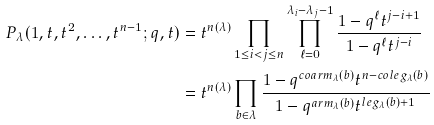<formula> <loc_0><loc_0><loc_500><loc_500>P _ { \lambda } ( 1 , t , t ^ { 2 } , \dots , t ^ { n - 1 } ; q , t ) & = t ^ { n ( \lambda ) } \prod _ { 1 \leq i < j \leq n } \prod _ { \ell = 0 } ^ { \lambda _ { i } - \lambda _ { j } - 1 } \frac { 1 - q ^ { \ell } t ^ { j - i + 1 } } { 1 - q ^ { \ell } t ^ { j - i } } \\ & = t ^ { n ( \lambda ) } \prod _ { b \in \lambda } \frac { 1 - q ^ { c o a r m _ { \lambda } ( b ) } t ^ { n - c o l e g _ { \lambda } ( b ) } } { 1 - q ^ { a r m _ { \lambda } ( b ) } t ^ { l e g _ { \lambda } ( b ) + 1 } }</formula> 